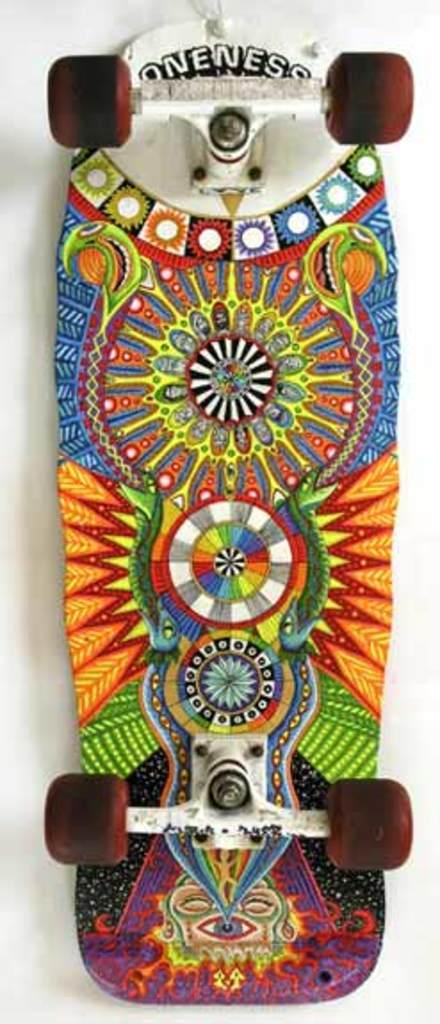What object is the main subject of the image? There is a skateboard in the image. Can you describe the appearance of the skateboard? The skateboard has a design. What color is the background of the image? The background of the image is white. What type of plastic material is used to make the curve on the skateboard? There is no curve mentioned on the skateboard in the image, and no information about the material used to make it. 